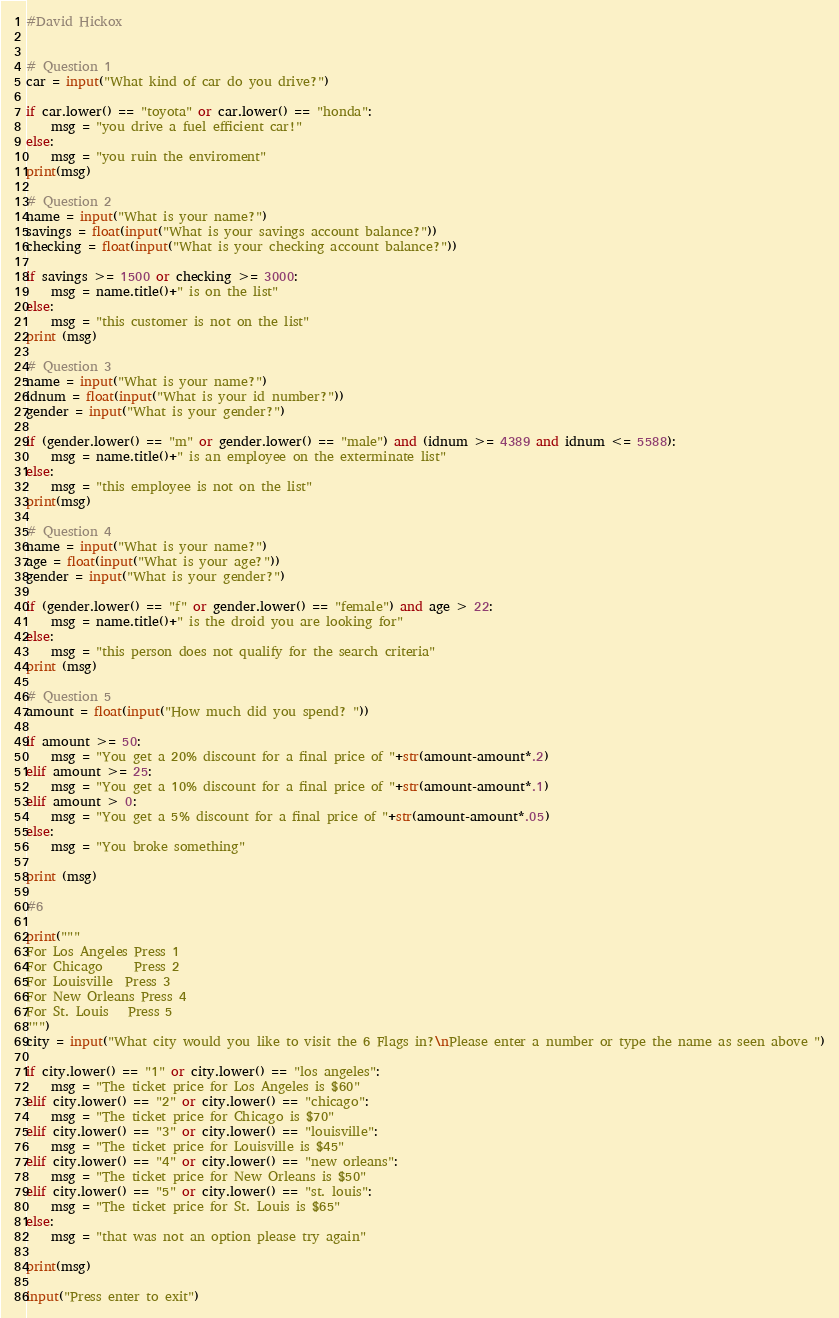Convert code to text. <code><loc_0><loc_0><loc_500><loc_500><_Python_>#David Hickox


# Question 1
car = input("What kind of car do you drive?")

if car.lower() == "toyota" or car.lower() == "honda":
    msg = "you drive a fuel efficient car!"
else:
    msg = "you ruin the enviroment"
print(msg)
    
# Question 2
name = input("What is your name?")
savings = float(input("What is your savings account balance?"))
checking = float(input("What is your checking account balance?"))

if savings >= 1500 or checking >= 3000:
    msg = name.title()+" is on the list"
else:
    msg = "this customer is not on the list"
print (msg)

# Question 3
name = input("What is your name?")
idnum = float(input("What is your id number?"))
gender = input("What is your gender?")

if (gender.lower() == "m" or gender.lower() == "male") and (idnum >= 4389 and idnum <= 5588):
    msg = name.title()+" is an employee on the exterminate list"
else:
    msg = "this employee is not on the list"
print(msg)

# Question 4
name = input("What is your name?")
age = float(input("What is your age?"))
gender = input("What is your gender?")

if (gender.lower() == "f" or gender.lower() == "female") and age > 22:
    msg = name.title()+" is the droid you are looking for"
else:
    msg = "this person does not qualify for the search criteria"
print (msg)

# Question 5 
amount = float(input("How much did you spend? "))

if amount >= 50:
    msg = "You get a 20% discount for a final price of "+str(amount-amount*.2)
elif amount >= 25:
    msg = "You get a 10% discount for a final price of "+str(amount-amount*.1)
elif amount > 0:
    msg = "You get a 5% discount for a final price of "+str(amount-amount*.05)
else:
    msg = "You broke something"

print (msg)

#6

print("""
For Los Angeles Press 1
For Chicago     Press 2
For Louisville  Press 3
For New Orleans Press 4
For St. Louis   Press 5
""")
city = input("What city would you like to visit the 6 Flags in?\nPlease enter a number or type the name as seen above ")

if city.lower() == "1" or city.lower() == "los angeles":
    msg = "The ticket price for Los Angeles is $60"
elif city.lower() == "2" or city.lower() == "chicago":
    msg = "The ticket price for Chicago is $70"
elif city.lower() == "3" or city.lower() == "louisville":
    msg = "The ticket price for Louisville is $45"
elif city.lower() == "4" or city.lower() == "new orleans":
    msg = "The ticket price for New Orleans is $50"
elif city.lower() == "5" or city.lower() == "st. louis":
    msg = "The ticket price for St. Louis is $65"
else:
    msg = "that was not an option please try again"

print(msg)

input("Press enter to exit")
</code> 